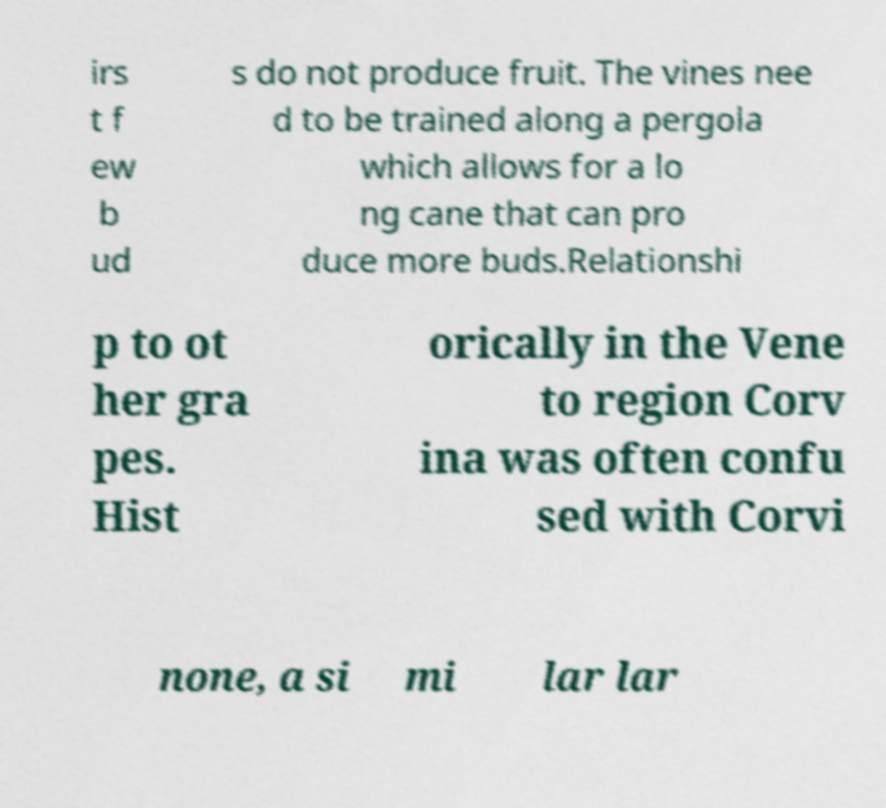Could you assist in decoding the text presented in this image and type it out clearly? irs t f ew b ud s do not produce fruit. The vines nee d to be trained along a pergola which allows for a lo ng cane that can pro duce more buds.Relationshi p to ot her gra pes. Hist orically in the Vene to region Corv ina was often confu sed with Corvi none, a si mi lar lar 